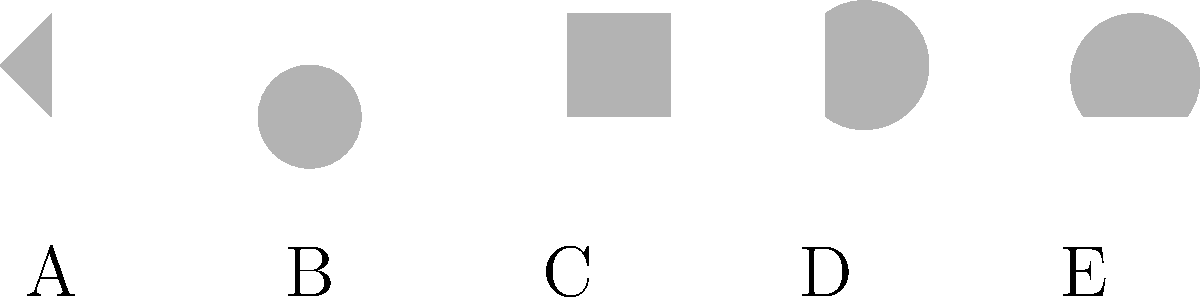Identify the leaf shape that would be most suitable for a plant species adapted to maximize photosynthesis in low-light conditions. Consider the silhouettes labeled A through E, and choose the one that would provide the greatest surface area relative to its size. To answer this question, we need to analyze each leaf shape and consider how it relates to photosynthetic efficiency in low-light conditions:

1. Shape A (Triangular): Has a relatively small surface area compared to its size.
2. Shape B (Orbicular): Circular shape provides a good balance of surface area to size.
3. Shape C (Oblong): Rectangular shape offers a larger surface area than A, but not optimized.
4. Shape D (Ovate): Egg-shaped, provides a good surface area but not the maximum.
5. Shape E (Cordate): Heart-shaped, offers the largest surface area relative to its size.

In low-light conditions, maximizing photosynthesis requires maximizing the leaf surface area to capture as much light as possible. The cordate (heart-shaped) leaf, labeled E, provides the greatest surface area relative to its size due to its broad, rounded lobes and the indentation at the base which increases the perimeter without significantly reducing the overall area.

This shape allows for efficient light capture from multiple angles and maximizes the number of chloroplasts that can be exposed to limited light. The broad surface also allows for more efficient gas exchange, which is crucial for photosynthesis.

Therefore, the cordate leaf shape (E) would be most suitable for a plant species adapted to maximize photosynthesis in low-light conditions.
Answer: E (Cordate) 